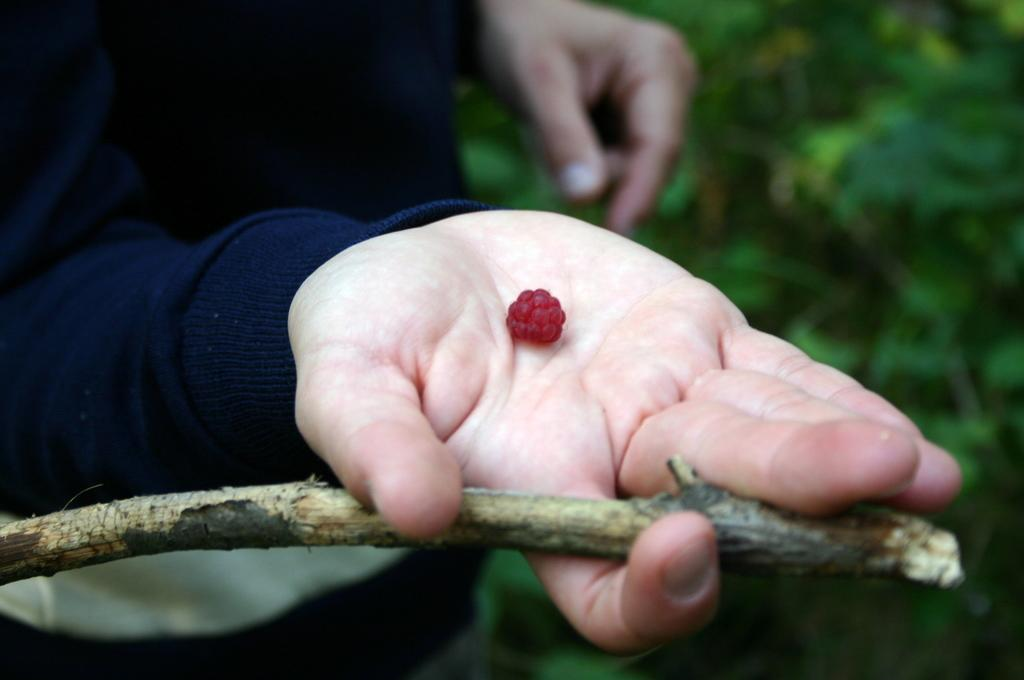What type of fruit is visible in the image? There is a tiny raspberry fruit in the image. Who is holding the raspberry fruit in the image? The raspberry fruit is in a person's hand. What part of the raspberry fruit is still attached to the fruit? There is a stem associated with the raspberry fruit. What type of meat is being served in the hall in the image? There is no mention of meat, a hall, or any serving in the image; it only features a tiny raspberry fruit in a person's hand. 